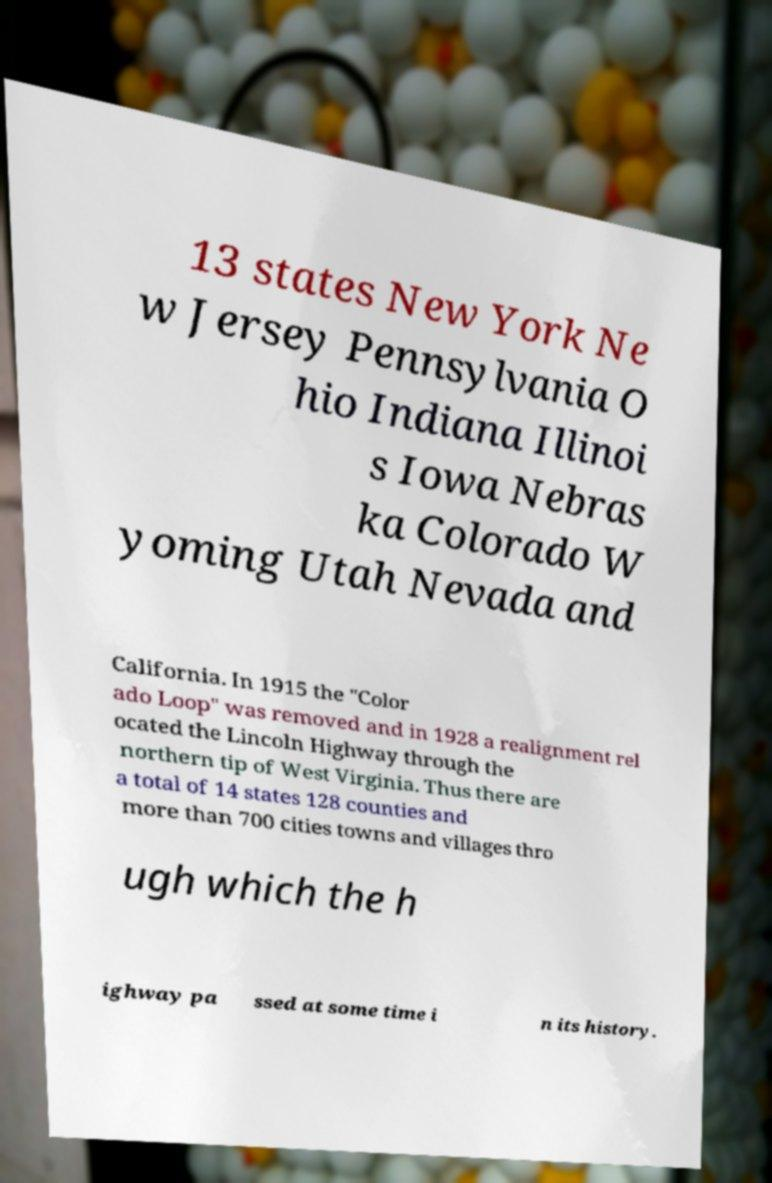I need the written content from this picture converted into text. Can you do that? 13 states New York Ne w Jersey Pennsylvania O hio Indiana Illinoi s Iowa Nebras ka Colorado W yoming Utah Nevada and California. In 1915 the "Color ado Loop" was removed and in 1928 a realignment rel ocated the Lincoln Highway through the northern tip of West Virginia. Thus there are a total of 14 states 128 counties and more than 700 cities towns and villages thro ugh which the h ighway pa ssed at some time i n its history. 